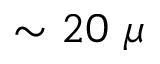<formula> <loc_0><loc_0><loc_500><loc_500>\sim 2 0 \mu</formula> 